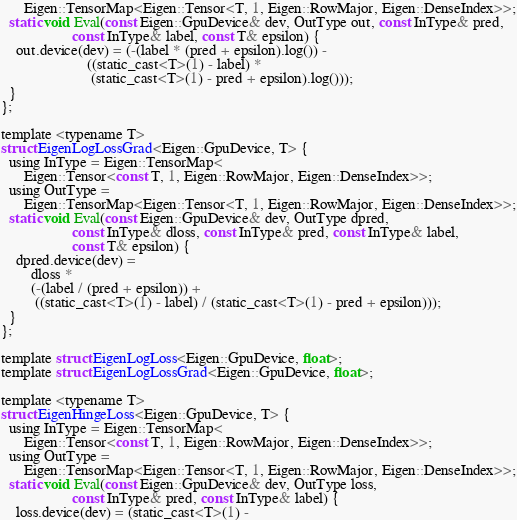Convert code to text. <code><loc_0><loc_0><loc_500><loc_500><_Cuda_>      Eigen::TensorMap<Eigen::Tensor<T, 1, Eigen::RowMajor, Eigen::DenseIndex>>;
  static void Eval(const Eigen::GpuDevice& dev, OutType out, const InType& pred,
                   const InType& label, const T& epsilon) {
    out.device(dev) = (-(label * (pred + epsilon).log()) -
                       ((static_cast<T>(1) - label) *
                        (static_cast<T>(1) - pred + epsilon).log()));
  }
};

template <typename T>
struct EigenLogLossGrad<Eigen::GpuDevice, T> {
  using InType = Eigen::TensorMap<
      Eigen::Tensor<const T, 1, Eigen::RowMajor, Eigen::DenseIndex>>;
  using OutType =
      Eigen::TensorMap<Eigen::Tensor<T, 1, Eigen::RowMajor, Eigen::DenseIndex>>;
  static void Eval(const Eigen::GpuDevice& dev, OutType dpred,
                   const InType& dloss, const InType& pred, const InType& label,
                   const T& epsilon) {
    dpred.device(dev) =
        dloss *
        (-(label / (pred + epsilon)) +
         ((static_cast<T>(1) - label) / (static_cast<T>(1) - pred + epsilon)));
  }
};

template struct EigenLogLoss<Eigen::GpuDevice, float>;
template struct EigenLogLossGrad<Eigen::GpuDevice, float>;

template <typename T>
struct EigenHingeLoss<Eigen::GpuDevice, T> {
  using InType = Eigen::TensorMap<
      Eigen::Tensor<const T, 1, Eigen::RowMajor, Eigen::DenseIndex>>;
  using OutType =
      Eigen::TensorMap<Eigen::Tensor<T, 1, Eigen::RowMajor, Eigen::DenseIndex>>;
  static void Eval(const Eigen::GpuDevice& dev, OutType loss,
                   const InType& pred, const InType& label) {
    loss.device(dev) = (static_cast<T>(1) -</code> 